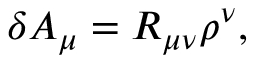Convert formula to latex. <formula><loc_0><loc_0><loc_500><loc_500>\delta A _ { \mu } = R _ { \mu \nu } \rho ^ { \nu } ,</formula> 